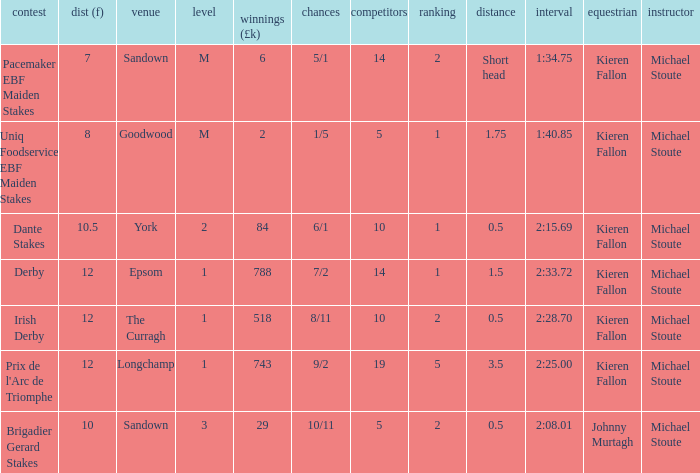Name the least runners with dist of 10.5 10.0. 